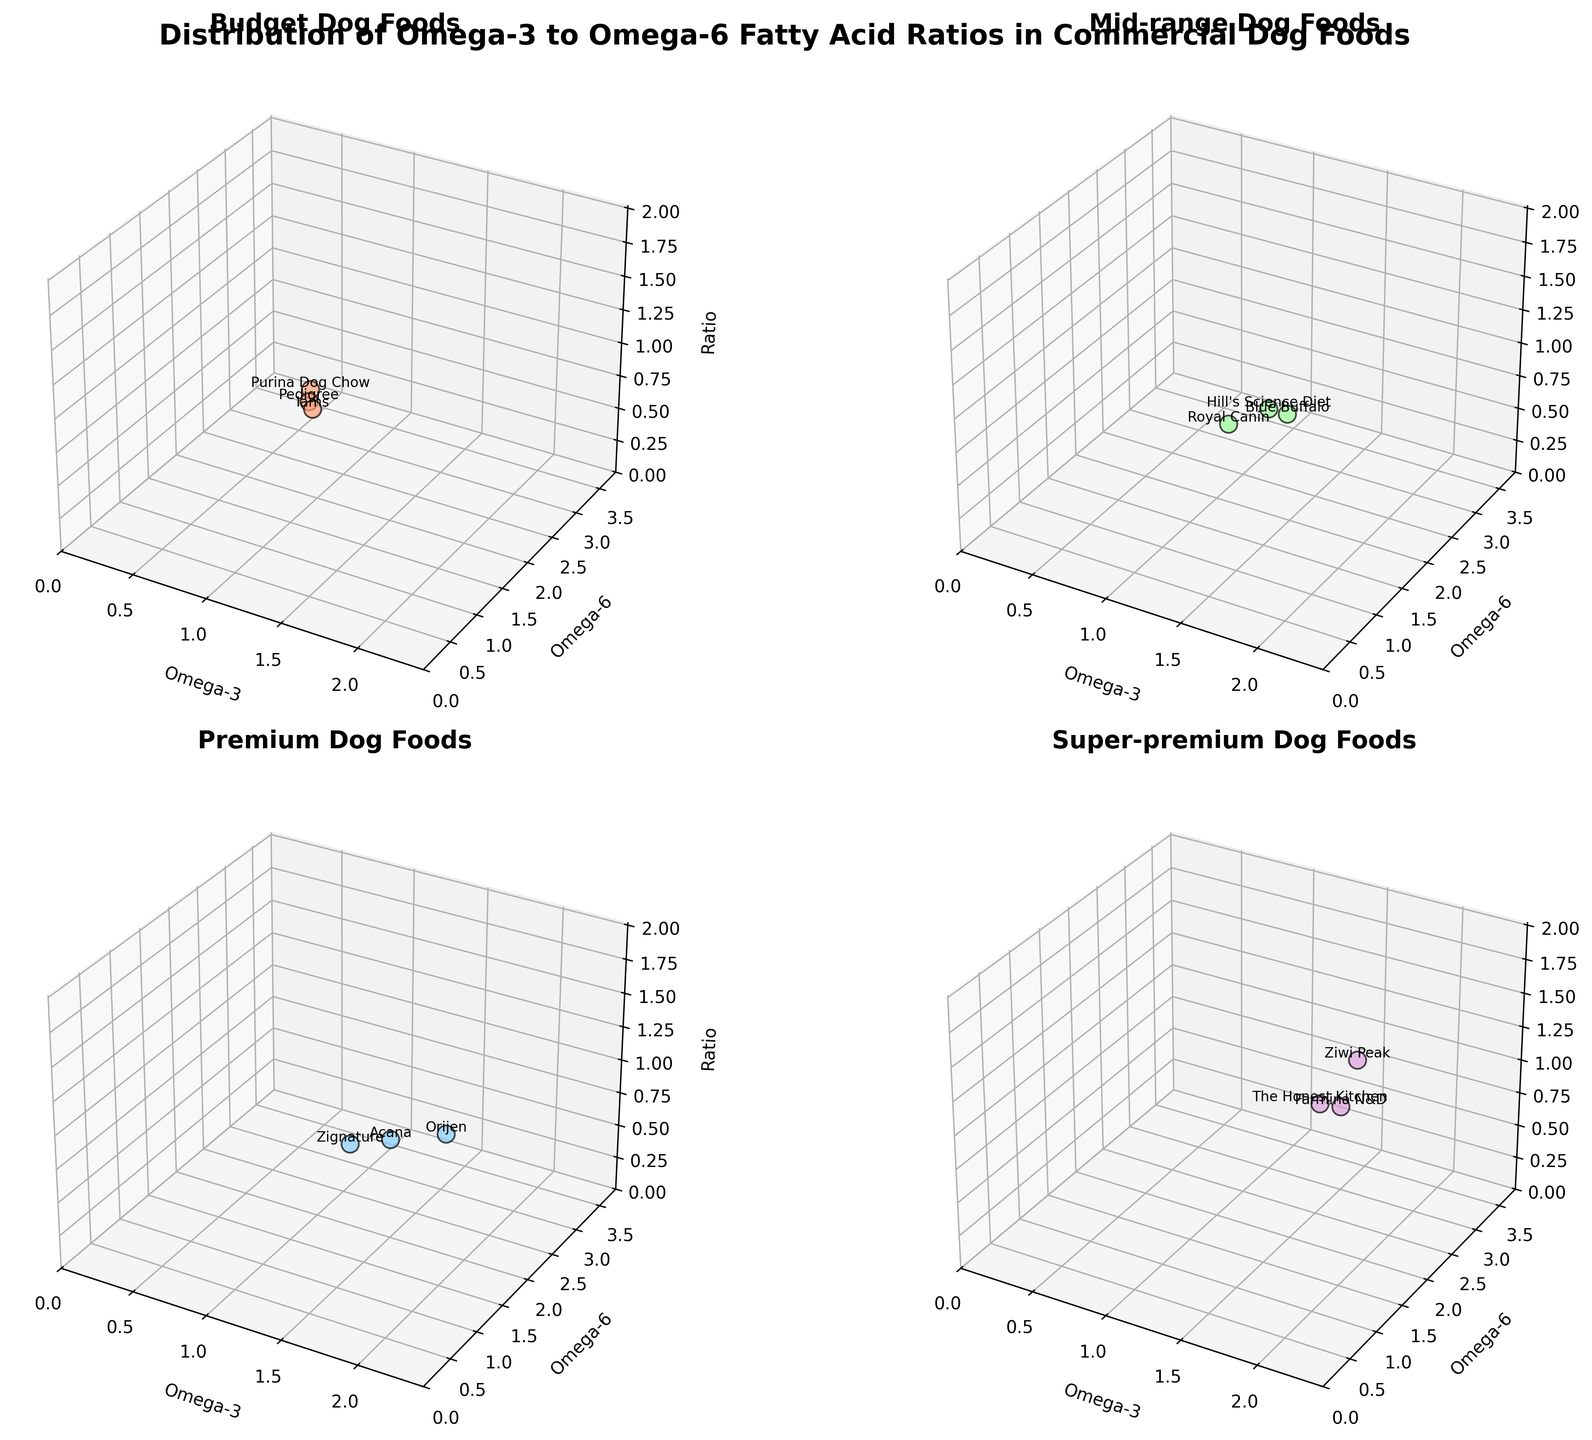What's the title of the figure? The title is labeled at the top of the figure and clearly summarizes what the figure is about. It reads, "Distribution of Omega-3 to Omega-6 Fatty Acid Ratios in Commercial Dog Foods."
Answer: "Distribution of Omega-3 to Omega-6 Fatty Acid Ratios in Commercial Dog Foods." In which price point category do you find the highest ratio value? The highest ratio can be found by comparing the ratio values in the z-axis for each subplot. The "super-premium" category clearly has the highest value, which is 1.833 for Ziwi Peak.
Answer: super-premium Which brand in the mid-range category has the lowest omega-6 value? The mid-range subplot shows three brands. By comparing their omega-6 values on the y-axis, we see that Royal Canin has the lowest omega-6 value of 2.5.
Answer: Royal Canin How many brands are represented in the premium category? The premium category subplot shows the number of brands by counting the data points present. There are three brands: Orijen, Acana, and Zignature.
Answer: Three Which brand has the highest omega-3 value in the figure? By checking the omega-3 values in the x-axis across all subplots, the highest value is found in the super-premium category at 2.2 for Ziwi Peak.
Answer: Ziwi Peak How does the ratio of omega-3 to omega-6 compare between Orijen and The Honest Kitchen? Orijen in the premium category has a ratio of 0.818. The Honest Kitchen in the super-premium category has a ratio of 1.357. By comparing these two, The Honest Kitchen has a higher ratio.
Answer: The Honest Kitchen has a higher ratio Is there any brand with a higher omega-6 than omega-3 content? By examining the values on the x (omega-3) and y (omega-6) axes, it’s clear that every brand in the figure has a higher omega-6 than omega-3 content.
Answer: Yes Are there any brands with an omega-3 value greater than 1.8? Look at the x-axis values. In the super-premium subplot, Farmina N&D has an omega-3 value of 2.0, and Ziwi Peak has a 2.2 value. Both are greater than 1.8.
Answer: Yes 